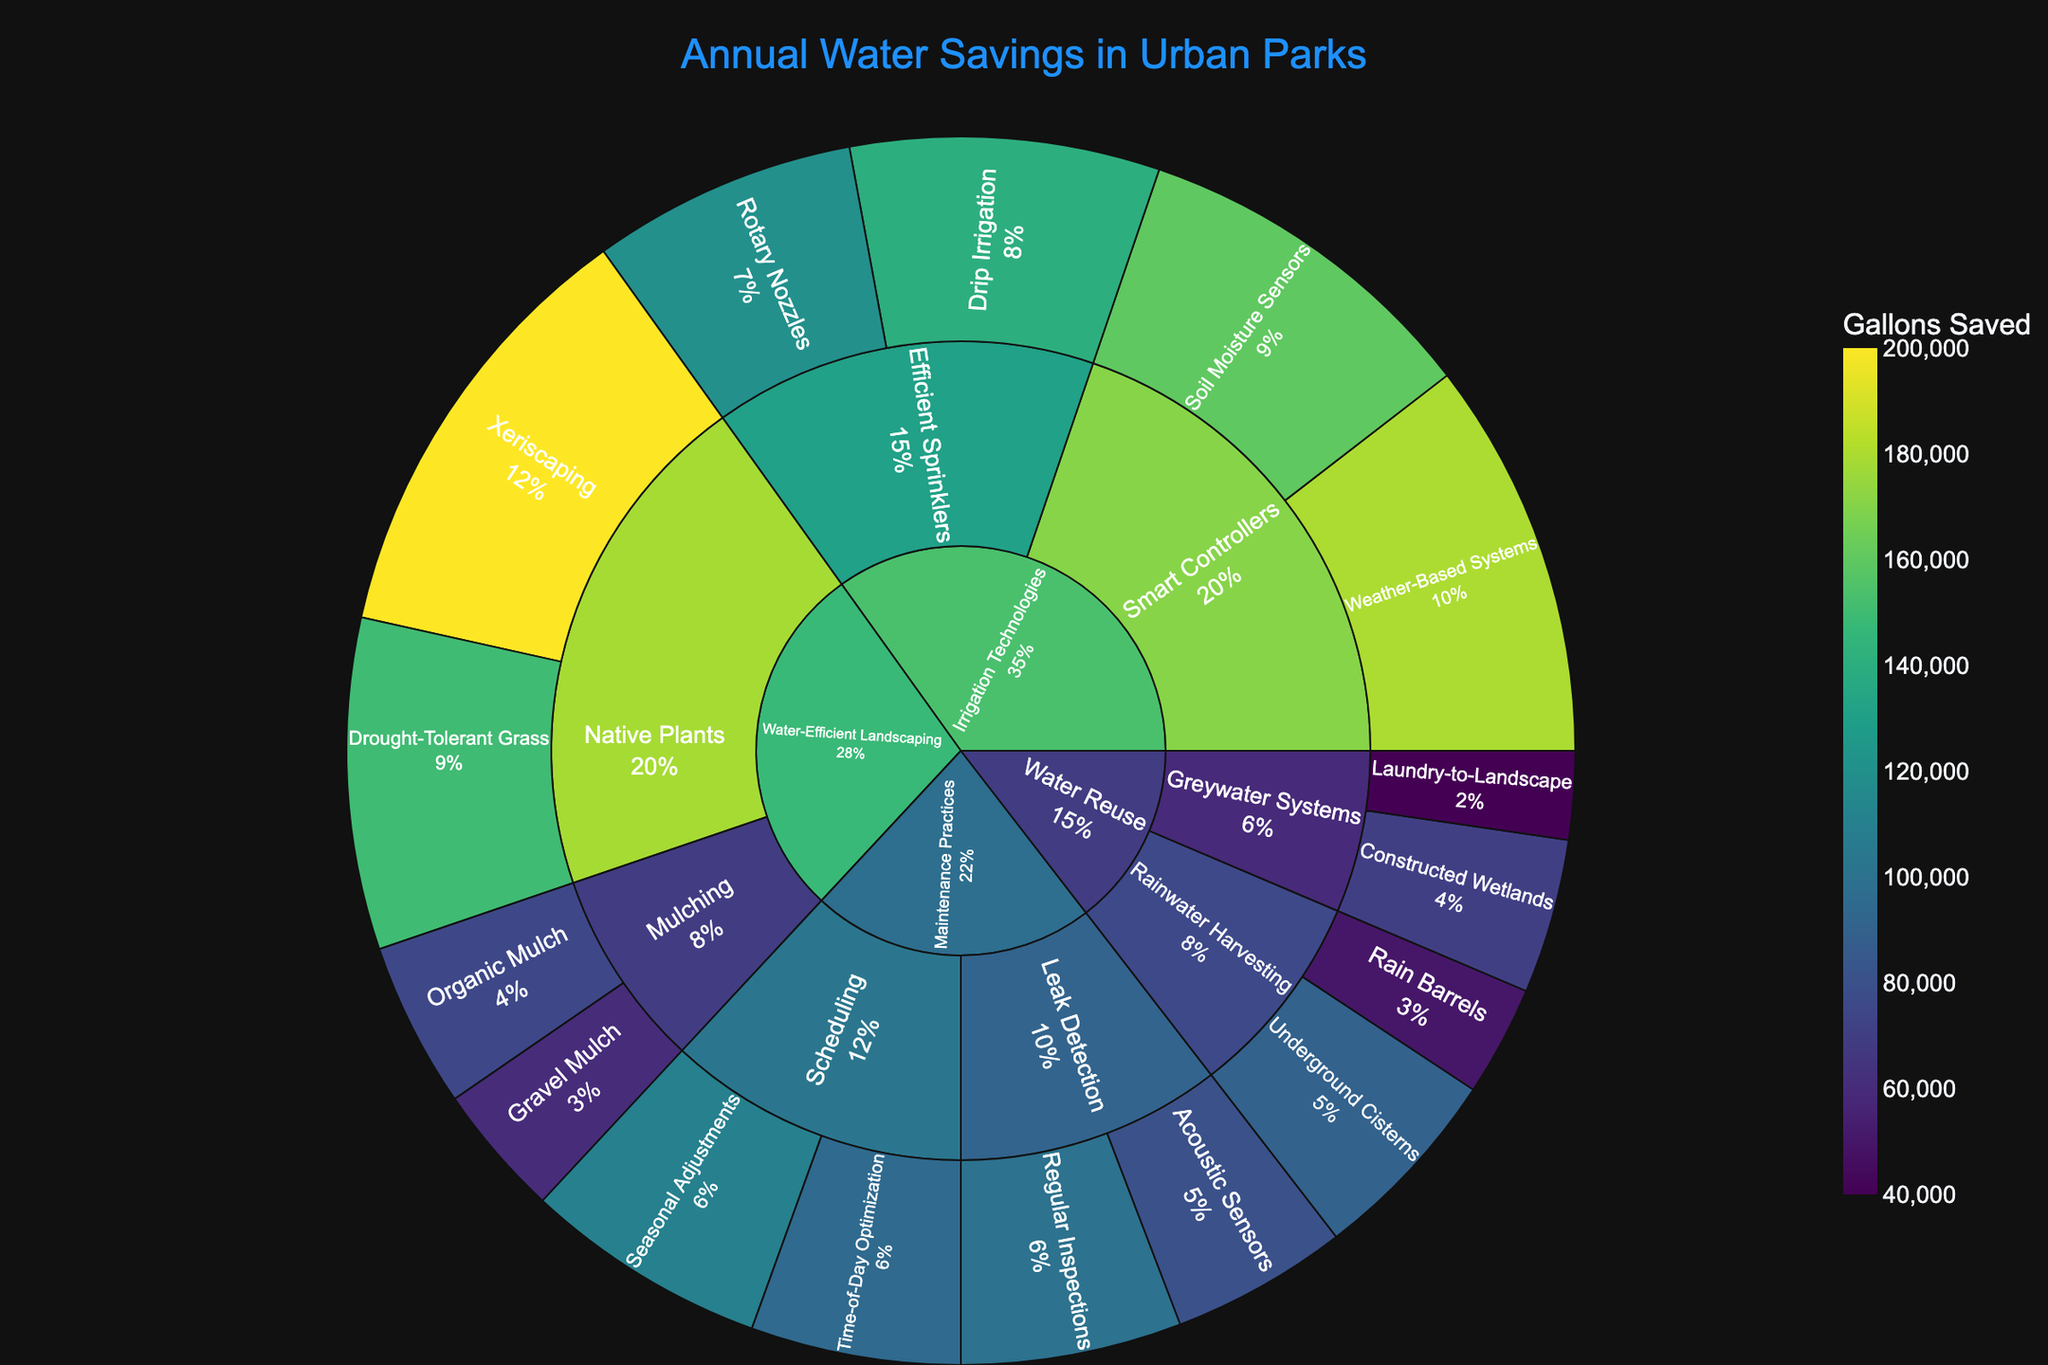What's the title of the figure? The title of the figure is usually located at the top center of the plot. In this case, it reads 'Annual Water Savings in Urban Parks'.
Answer: Annual Water Savings in Urban Parks How many main categories are present in the plot? The outermost layer of the sunburst plot represents the main categories. By visually inspecting the plot, you'll see the main categories listed.
Answer: Four Which category has the highest annual water savings? To find this, look for the largest segment in the outer circle of the sunburst plot. This segment represents the category with the highest total savings.
Answer: Water-Efficient Landscaping Which technique saves more water, 'Weather-Based Systems' or 'Soil Moisture Sensors'? Locate both techniques within their category ('Smart Controllers' under 'Irrigation Technologies') and compare their savings as displayed on the plot. 'Weather-Based Systems' saves 180,000 gallons whereas 'Soil Moisture Sensors' saves 160,000 gallons.
Answer: Weather-Based Systems How much total water savings do Water Reuse techniques achieve? Sum the values of all techniques under the 'Water Reuse' category: Rain Barrels (50,000) + Underground Cisterns (90,000) + Laundry-to-Landscape (40,000) + Constructed Wetlands (70,000). The total is 250,000 gallons of water saved.
Answer: 250,000 gallons What percentage of the total savings is achieved by 'Drip Irrigation'? First, find the savings for 'Drip Irrigation' (140,000 gallons). Then, find all the savings sums and calculate the percentage: \( \frac{140,000}{\text{Total Savings}} \times 100 \). If the total savings are 1,485,000 gallons, then: \( \frac{140,000}{1,485,000} \times 100 \approx 9.42\%.
Answer: 9.42% Which subcategory under 'Maintenance Practices' achieves the least amount of water savings? Look at the subcategories under 'Maintenance Practices' and identify the smallest segment. 'Leak Detection' contributes savings of 100,000 (Regular Inspections) + 80,000 (Acoustic Sensors) = 180,000 gallons. 'Scheduling' contributes a total of 205,000 gallons (110,000 for Seasonal Adjustments and 95,000 for Time-of-Day Optimization), so 'Leak Detection' achieves less water savings.
Answer: Leak Detection What is the most effective technique under 'Water-Efficient Landscaping'? Within 'Water-Efficient Landscaping', compare the savings values for each technique. The technique with the highest savings is 'Xeriscaping' with 200,000 gallons saved.
Answer: Xeriscaping 